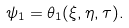<formula> <loc_0><loc_0><loc_500><loc_500>\psi _ { 1 } = \theta _ { 1 } ( \xi , \eta , \tau ) .</formula> 